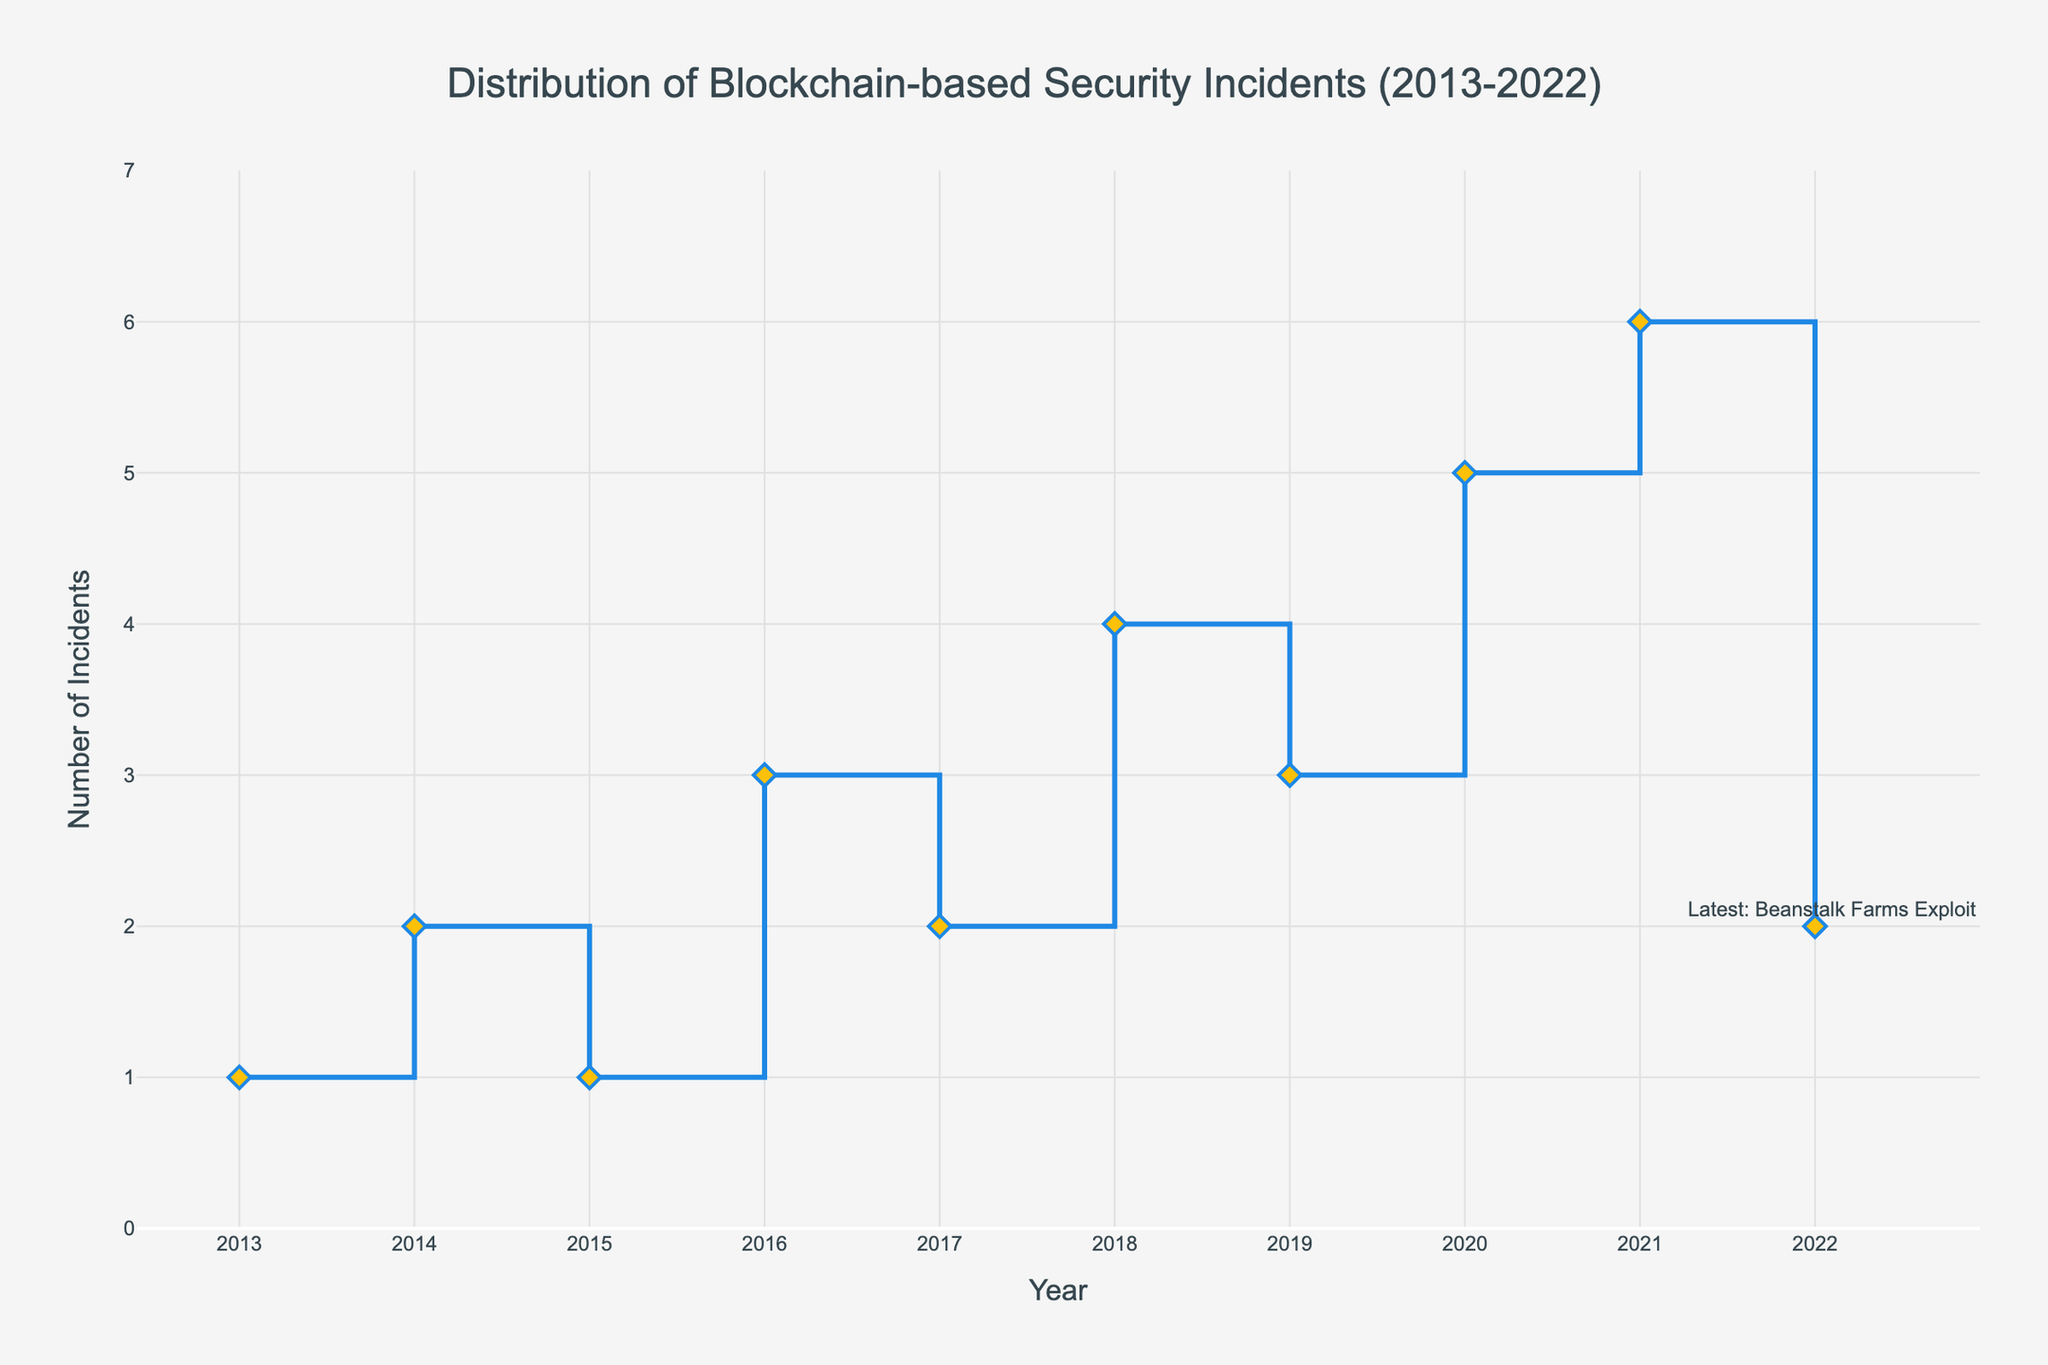What is the title of the figure? The title is usually placed at the top of the figure and often provides a summary of what the chart represents. In this case, the title is in a larger and bold font at the top center of the figure.
Answer: Distribution of Blockchain-based Security Incidents (2013-2022) What does the y-axis represent? The y-axis usually represents the dependent variable being measured. In this figure, it is labeled "Number of Incidents" indicating that it shows the count of security incidents for each year.
Answer: Number of Incidents Which year had the highest number of incidents? To find this, look for the highest point on the stair plot along the y-axis and note the corresponding year on the x-axis. The highest point is at 6 incidents in 2021.
Answer: 2021 How many incidents occurred in 2018? Locate the year 2018 on the x-axis and then find the corresponding y-axis value. The plot shows 4 incidents in 2018.
Answer: 4 What is the total number of incidents from 2013 to 2022? Sum the y-values for each year from 2013 to 2022. The values are: 1, 2, 1, 3, 2, 4, 3, 5, 6, 2. Their sum is 29.
Answer: 29 Between which consecutive years was the largest increase in incidents observed? Examine the steps in the stair plot to identify the largest vertical jump. The largest increase is between 2019 (3 incidents) and 2020 (5 incidents).
Answer: Between 2019 and 2020 Which year had an equal number of incidents to 2017? In 2017, there were 2 incidents. Look for another year with the same y-value. Both 2014 and 2022 had 2 incidents.
Answer: 2014 and 2022 What is the average number of incidents per year from 2013 to 2022? To find the average, sum the incidents for all years (29) and divide by the number of years (10). 29/10 = 2.9.
Answer: 2.9 How did the number of incidents change from 2016 to 2017? Compare the y-values for 2016 (3 incidents) and 2017 (2 incidents). The number decreased by 1 incident.
Answer: Decreased by 1 What was the most recent incident mentioned in the figure? Check the annotation at the latest year, which is 2022, noting the incident associated with this data point. The annotation states 'Latest: Beanstalk Farms Exploit'.
Answer: Beanstalk Farms Exploit 